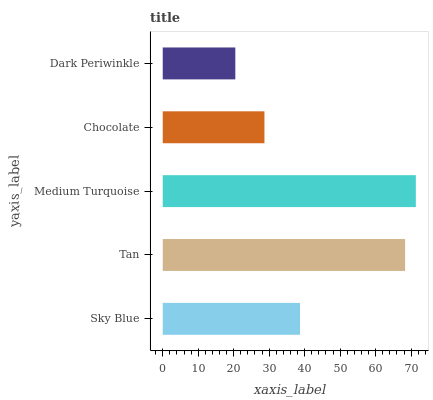Is Dark Periwinkle the minimum?
Answer yes or no. Yes. Is Medium Turquoise the maximum?
Answer yes or no. Yes. Is Tan the minimum?
Answer yes or no. No. Is Tan the maximum?
Answer yes or no. No. Is Tan greater than Sky Blue?
Answer yes or no. Yes. Is Sky Blue less than Tan?
Answer yes or no. Yes. Is Sky Blue greater than Tan?
Answer yes or no. No. Is Tan less than Sky Blue?
Answer yes or no. No. Is Sky Blue the high median?
Answer yes or no. Yes. Is Sky Blue the low median?
Answer yes or no. Yes. Is Chocolate the high median?
Answer yes or no. No. Is Medium Turquoise the low median?
Answer yes or no. No. 